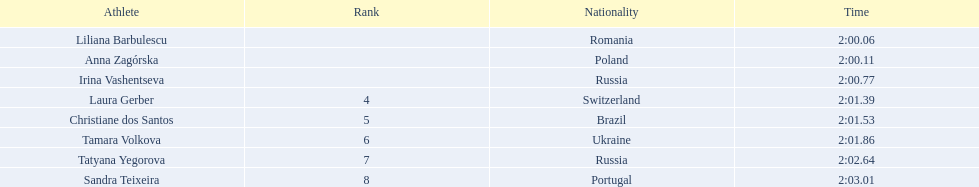Parse the table in full. {'header': ['Athlete', 'Rank', 'Nationality', 'Time'], 'rows': [['Liliana Barbulescu', '', 'Romania', '2:00.06'], ['Anna Zagórska', '', 'Poland', '2:00.11'], ['Irina Vashentseva', '', 'Russia', '2:00.77'], ['Laura Gerber', '4', 'Switzerland', '2:01.39'], ['Christiane dos Santos', '5', 'Brazil', '2:01.53'], ['Tamara Volkova', '6', 'Ukraine', '2:01.86'], ['Tatyana Yegorova', '7', 'Russia', '2:02.64'], ['Sandra Teixeira', '8', 'Portugal', '2:03.01']]} What are the names of the competitors? Liliana Barbulescu, Anna Zagórska, Irina Vashentseva, Laura Gerber, Christiane dos Santos, Tamara Volkova, Tatyana Yegorova, Sandra Teixeira. Which finalist finished the fastest? Liliana Barbulescu. 